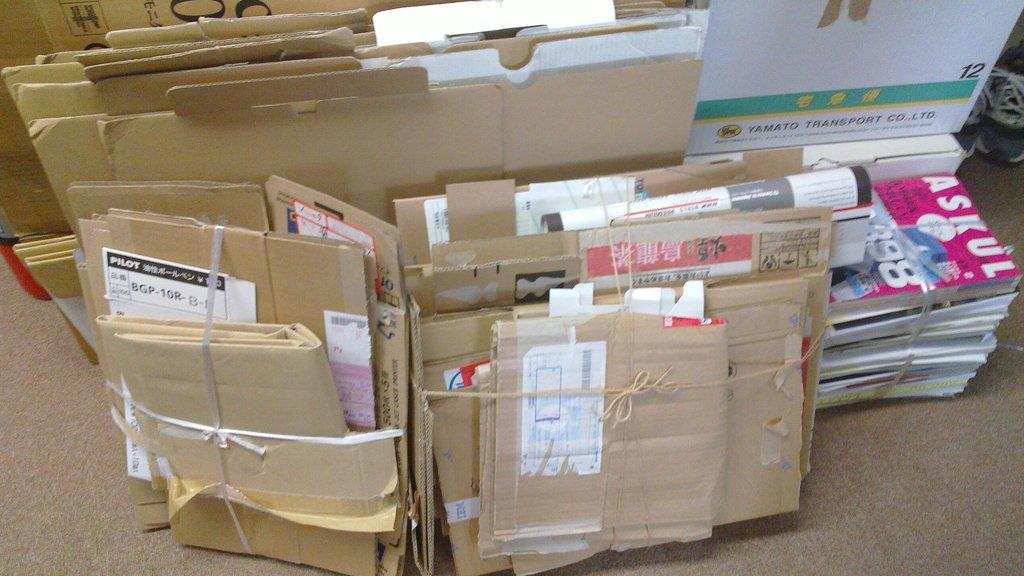<image>
Describe the image concisely. An Askul magazine is on top of a pile of mail. 